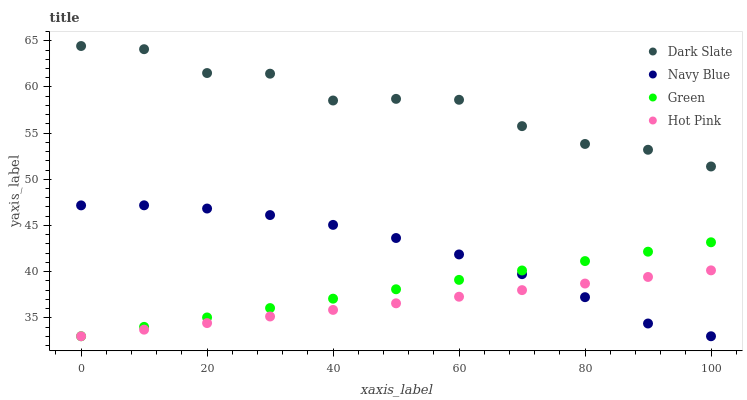Does Hot Pink have the minimum area under the curve?
Answer yes or no. Yes. Does Dark Slate have the maximum area under the curve?
Answer yes or no. Yes. Does Green have the minimum area under the curve?
Answer yes or no. No. Does Green have the maximum area under the curve?
Answer yes or no. No. Is Hot Pink the smoothest?
Answer yes or no. Yes. Is Dark Slate the roughest?
Answer yes or no. Yes. Is Green the smoothest?
Answer yes or no. No. Is Green the roughest?
Answer yes or no. No. Does Hot Pink have the lowest value?
Answer yes or no. Yes. Does Dark Slate have the highest value?
Answer yes or no. Yes. Does Green have the highest value?
Answer yes or no. No. Is Navy Blue less than Dark Slate?
Answer yes or no. Yes. Is Dark Slate greater than Hot Pink?
Answer yes or no. Yes. Does Green intersect Hot Pink?
Answer yes or no. Yes. Is Green less than Hot Pink?
Answer yes or no. No. Is Green greater than Hot Pink?
Answer yes or no. No. Does Navy Blue intersect Dark Slate?
Answer yes or no. No. 